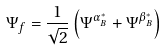Convert formula to latex. <formula><loc_0><loc_0><loc_500><loc_500>\Psi _ { f } = \frac { 1 } { \sqrt { 2 } } \left ( { \Psi ^ { \alpha _ { B } ^ { \ast } } + \Psi ^ { \beta _ { B } ^ { \ast } } } \right )</formula> 